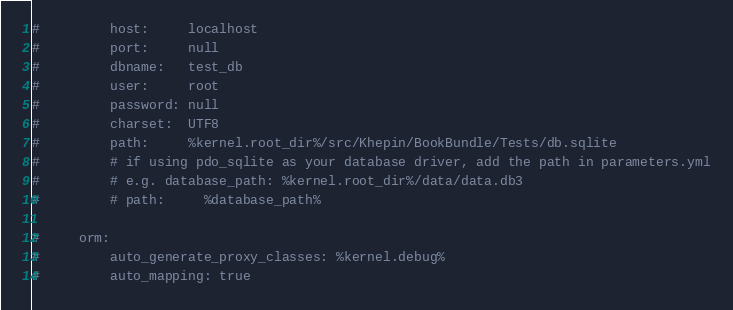<code> <loc_0><loc_0><loc_500><loc_500><_YAML_>#         host:     localhost
#         port:     null
#         dbname:   test_db
#         user:     root
#         password: null
#         charset:  UTF8
#         path:     %kernel.root_dir%/src/Khepin/BookBundle/Tests/db.sqlite
#         # if using pdo_sqlite as your database driver, add the path in parameters.yml
#         # e.g. database_path: %kernel.root_dir%/data/data.db3
#         # path:     %database_path%

#     orm:
#         auto_generate_proxy_classes: %kernel.debug%
#         auto_mapping: true</code> 